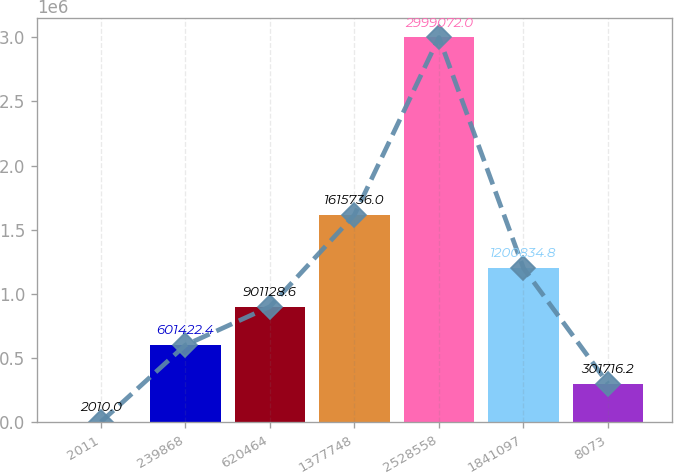Convert chart. <chart><loc_0><loc_0><loc_500><loc_500><bar_chart><fcel>2011<fcel>239868<fcel>620464<fcel>1377748<fcel>2528558<fcel>1841097<fcel>8073<nl><fcel>2010<fcel>601422<fcel>901129<fcel>1.61574e+06<fcel>2.99907e+06<fcel>1.20083e+06<fcel>301716<nl></chart> 